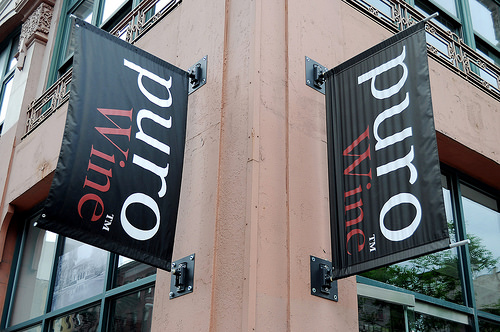<image>
Is the name plate on the window? No. The name plate is not positioned on the window. They may be near each other, but the name plate is not supported by or resting on top of the window. 